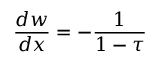<formula> <loc_0><loc_0><loc_500><loc_500>{ \frac { d w } { d x } } = - { \frac { 1 } { 1 - \tau } }</formula> 